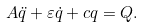<formula> <loc_0><loc_0><loc_500><loc_500>A \ddot { q } + \varepsilon \dot { q } + c q = Q .</formula> 